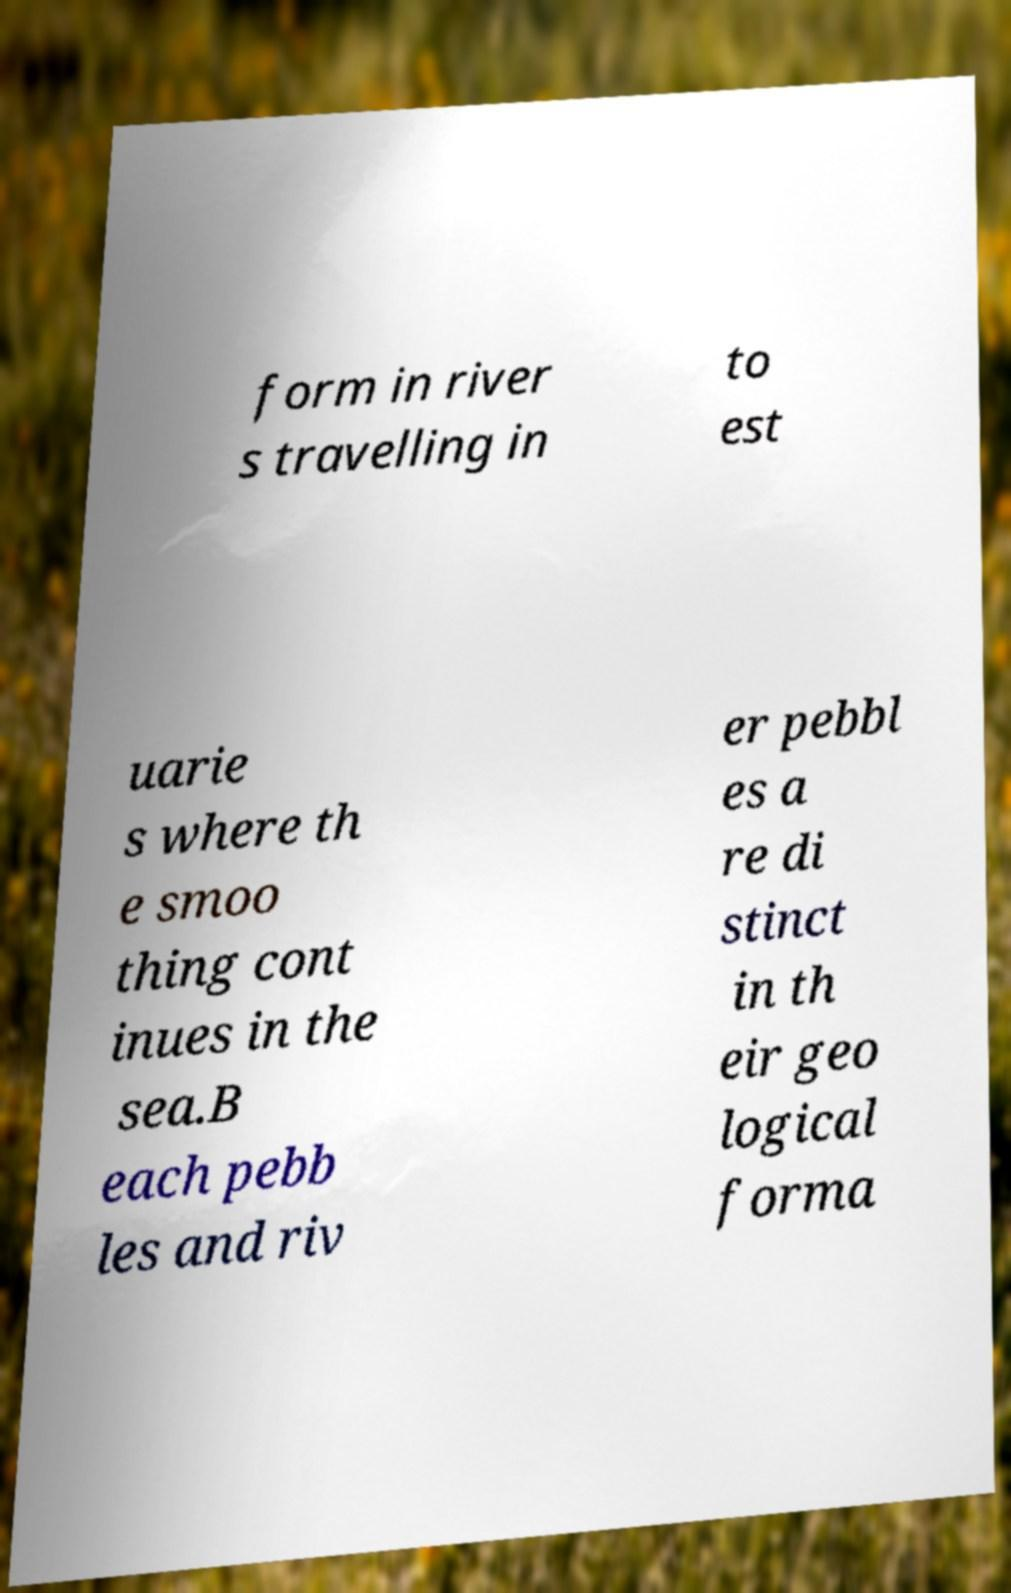Could you extract and type out the text from this image? form in river s travelling in to est uarie s where th e smoo thing cont inues in the sea.B each pebb les and riv er pebbl es a re di stinct in th eir geo logical forma 